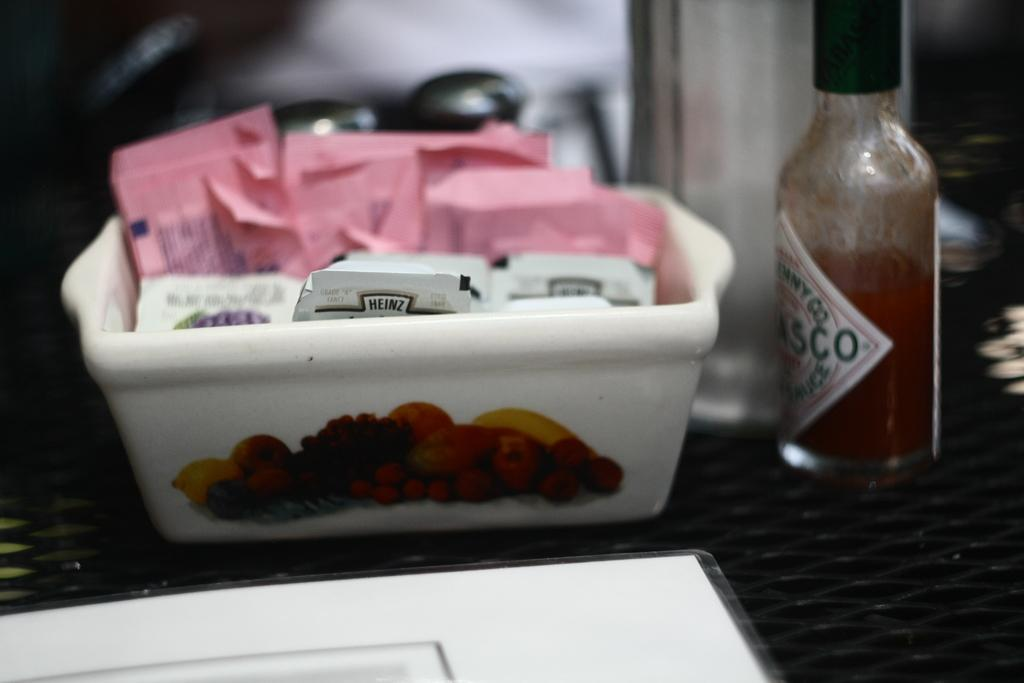What is in the bowl that is visible in the image? The bowl contains packets in the image. What else can be seen in the image besides the bowl? There is a bottle on the left side of the image. What color is the crayon on the right side of the image? There is no crayon present in the image. How much change is visible in the image? There is no change visible in the image. 